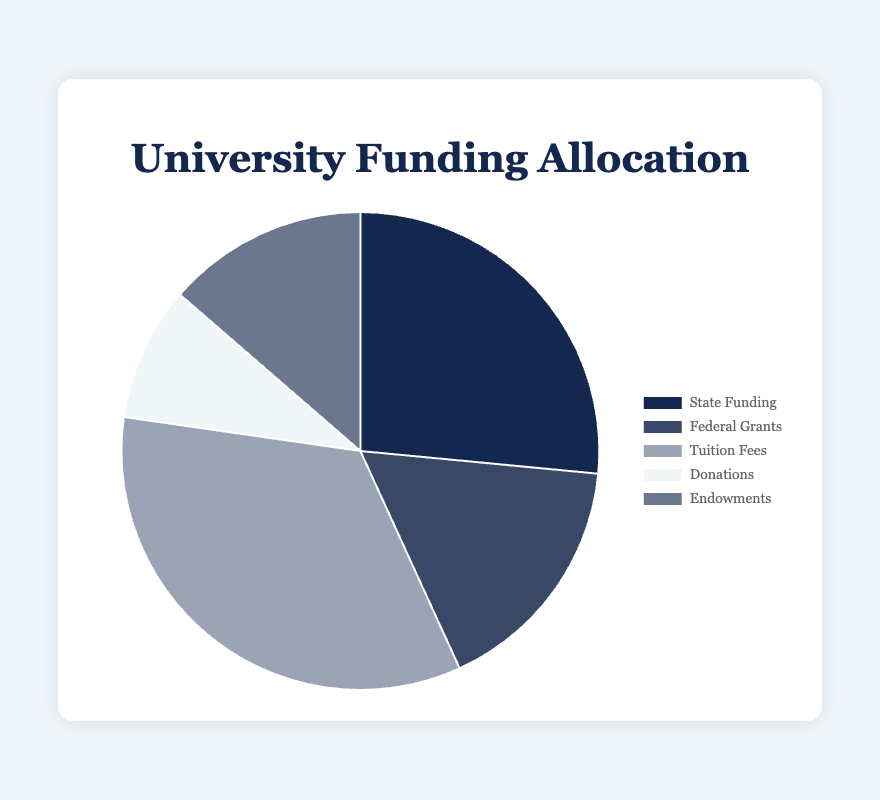Which funding source contributes the most to the total allocation? The source with the highest amount is Tuition Fees at $45,000,000. By comparing all the amounts, Tuition Fees have the greatest value.
Answer: Tuition Fees Which funding source has the least contribution? The smallest amount is Donations at $12,000,000. We compare all the values and Donations have the lowest figure.
Answer: Donations What is the total amount of funding? Add up all the sources: $35,000,000 (State Funding) + $22,000,000 (Federal Grants) + $45,000,000 (Tuition Fees) + $12,000,000 (Donations) + $18,000,000 (Endowments) = $132,000,000.
Answer: $132,000,000 How much more funding does Tuition Fees generate compared to Donations? The difference between Tuition Fees and Donations is $45,000,000 - $12,000,000 = $33,000,000.
Answer: $33,000,000 What percentage of the total funding does Endowments represent? Endowments are $18,000,000. The total funding is $132,000,000. The percentage is ($18,000,000 / $132,000,000) * 100 = 13.64%.
Answer: 13.64% Is the amount from Federal Grants more or less than from State Funding? Federal Grants amount to $22,000,000, which is less than State Funding at $35,000,000.
Answer: Less Which two sources together account for the highest percentage of the total funding? Adding Tuition Fees ($45,000,000) and State Funding ($35,000,000), the combined amount is $80,000,000, which is more than any other combination.
Answer: Tuition Fees and State Funding If Donations increased by $5,000,000, what would be the new total funding, and what percentage would Donations then represent? New Donations amount is $12,000,000 + $5,000,000 = $17,000,000. New total funding is $132,000,000 + $5,000,000 = $137,000,000. The new percentage is ($17,000,000 / $137,000,000) * 100 = 12.41%.
Answer: $137,000,000, 12.41% What is the combined amount of funding from Federal Grants and Endowments? Adding Federal Grants ($22,000,000) and Endowments ($18,000,000), the combined amount is $22,000,000 + $18,000,000 = $40,000,000.
Answer: $40,000,000 